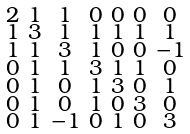<formula> <loc_0><loc_0><loc_500><loc_500>\begin{smallmatrix} 2 & 1 & 1 & 0 & 0 & 0 & 0 \\ 1 & 3 & 1 & 1 & 1 & 1 & 1 \\ 1 & 1 & 3 & 1 & 0 & 0 & - 1 \\ 0 & 1 & 1 & 3 & 1 & 1 & 0 \\ 0 & 1 & 0 & 1 & 3 & 0 & 1 \\ 0 & 1 & 0 & 1 & 0 & 3 & 0 \\ 0 & 1 & - 1 & 0 & 1 & 0 & 3 \end{smallmatrix}</formula> 